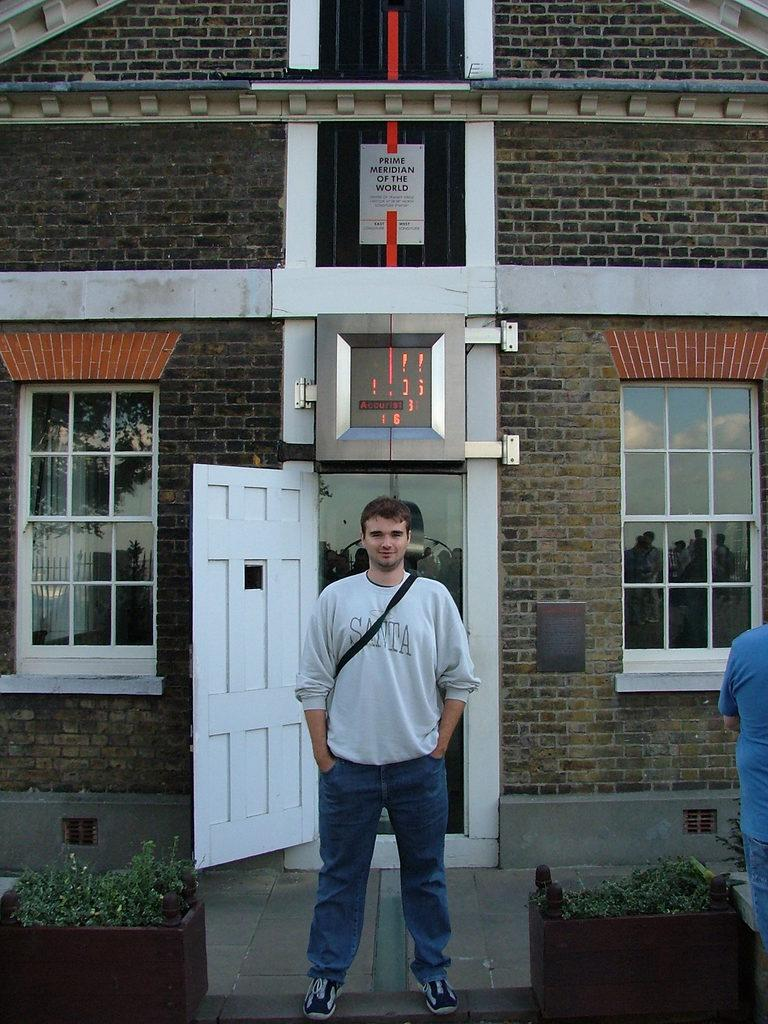Provide a one-sentence caption for the provided image. Man wearing a sweater that says Santa in front of a building. 